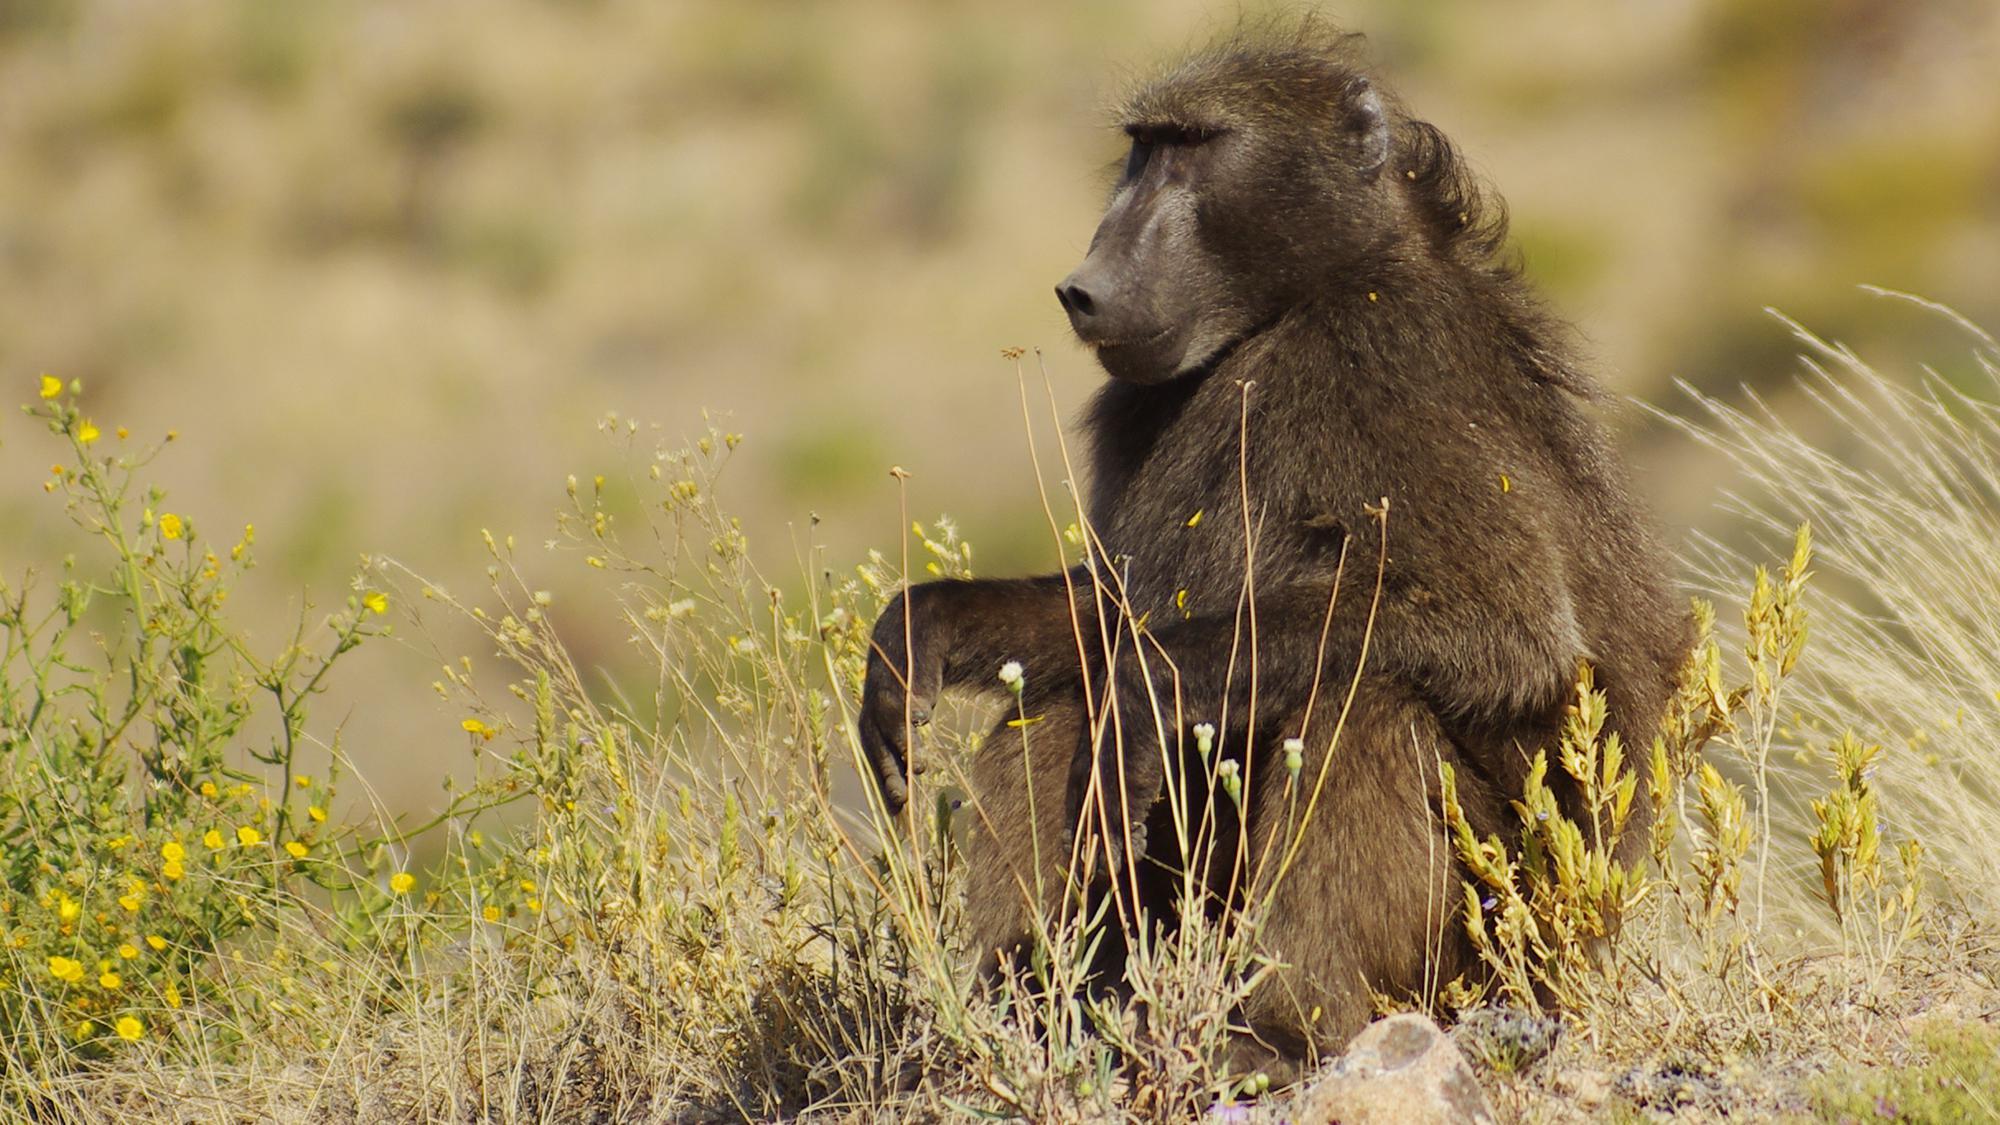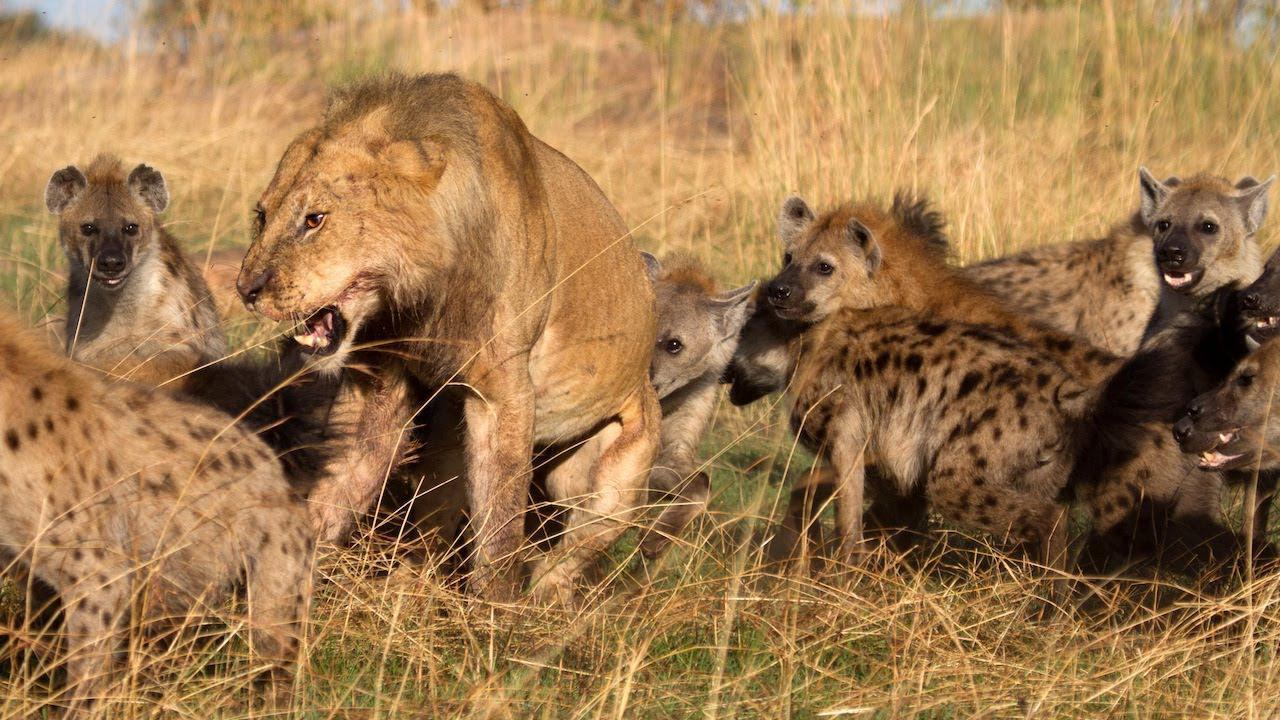The first image is the image on the left, the second image is the image on the right. For the images shown, is this caption "One baboon sits with bent knees and its body turned leftward, in an image." true? Answer yes or no. Yes. 